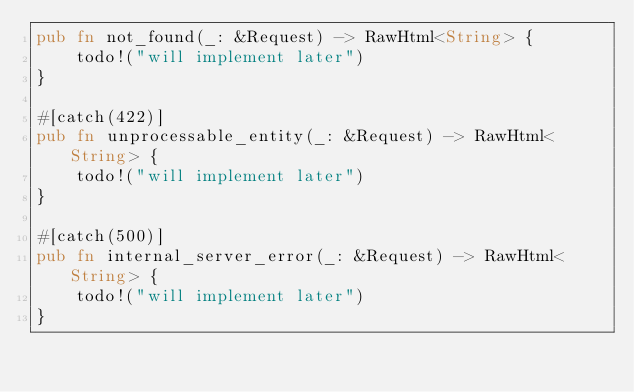<code> <loc_0><loc_0><loc_500><loc_500><_Rust_>pub fn not_found(_: &Request) -> RawHtml<String> {
    todo!("will implement later")
}

#[catch(422)]
pub fn unprocessable_entity(_: &Request) -> RawHtml<String> {
    todo!("will implement later")
}

#[catch(500)]
pub fn internal_server_error(_: &Request) -> RawHtml<String> {
    todo!("will implement later")
}
</code> 